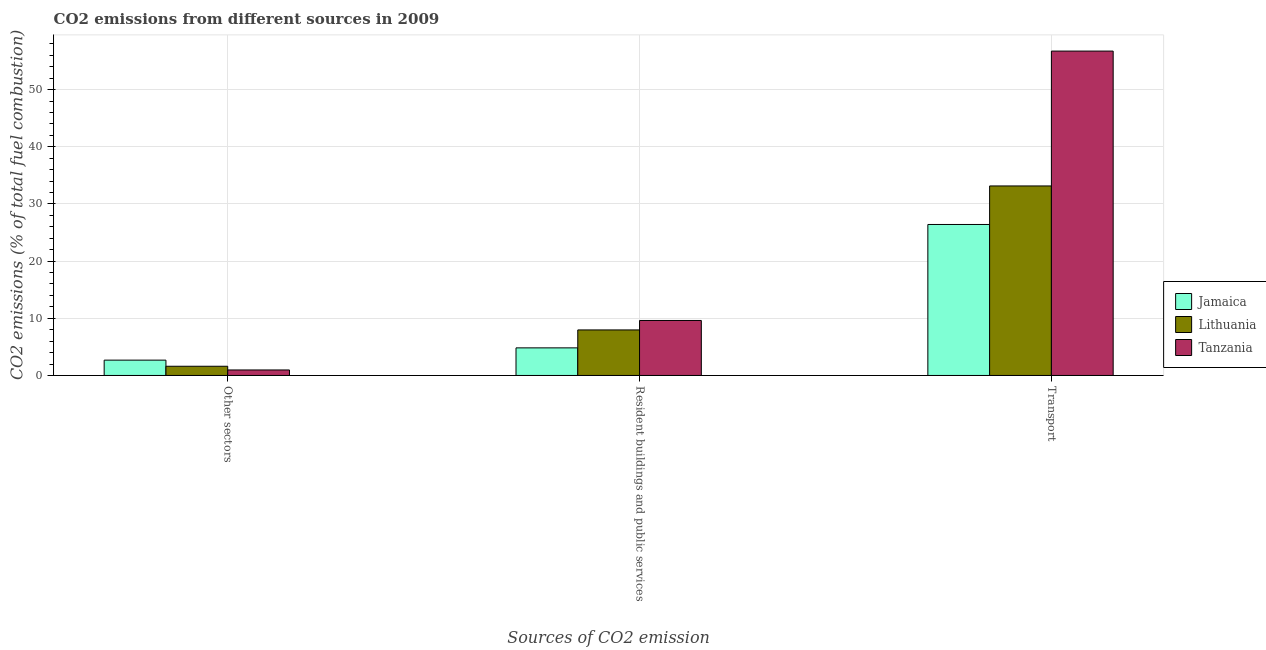How many different coloured bars are there?
Make the answer very short. 3. How many groups of bars are there?
Provide a succinct answer. 3. Are the number of bars on each tick of the X-axis equal?
Your answer should be compact. Yes. How many bars are there on the 3rd tick from the left?
Offer a very short reply. 3. How many bars are there on the 3rd tick from the right?
Give a very brief answer. 3. What is the label of the 1st group of bars from the left?
Your answer should be compact. Other sectors. What is the percentage of co2 emissions from other sectors in Lithuania?
Offer a terse response. 1.61. Across all countries, what is the maximum percentage of co2 emissions from resident buildings and public services?
Offer a terse response. 9.62. Across all countries, what is the minimum percentage of co2 emissions from other sectors?
Make the answer very short. 0.96. In which country was the percentage of co2 emissions from resident buildings and public services maximum?
Provide a short and direct response. Tanzania. In which country was the percentage of co2 emissions from transport minimum?
Provide a short and direct response. Jamaica. What is the total percentage of co2 emissions from other sectors in the graph?
Ensure brevity in your answer.  5.25. What is the difference between the percentage of co2 emissions from other sectors in Jamaica and that in Lithuania?
Offer a terse response. 1.07. What is the difference between the percentage of co2 emissions from transport in Jamaica and the percentage of co2 emissions from other sectors in Lithuania?
Make the answer very short. 24.8. What is the average percentage of co2 emissions from transport per country?
Give a very brief answer. 38.76. What is the difference between the percentage of co2 emissions from resident buildings and public services and percentage of co2 emissions from transport in Tanzania?
Offer a very short reply. -47.12. What is the ratio of the percentage of co2 emissions from resident buildings and public services in Tanzania to that in Jamaica?
Give a very brief answer. 1.99. What is the difference between the highest and the second highest percentage of co2 emissions from resident buildings and public services?
Offer a very short reply. 1.65. What is the difference between the highest and the lowest percentage of co2 emissions from other sectors?
Your answer should be compact. 1.72. In how many countries, is the percentage of co2 emissions from other sectors greater than the average percentage of co2 emissions from other sectors taken over all countries?
Your response must be concise. 1. Is the sum of the percentage of co2 emissions from other sectors in Tanzania and Jamaica greater than the maximum percentage of co2 emissions from transport across all countries?
Provide a succinct answer. No. What does the 1st bar from the left in Other sectors represents?
Provide a succinct answer. Jamaica. What does the 2nd bar from the right in Resident buildings and public services represents?
Provide a succinct answer. Lithuania. Is it the case that in every country, the sum of the percentage of co2 emissions from other sectors and percentage of co2 emissions from resident buildings and public services is greater than the percentage of co2 emissions from transport?
Provide a succinct answer. No. How many countries are there in the graph?
Offer a very short reply. 3. What is the difference between two consecutive major ticks on the Y-axis?
Your answer should be very brief. 10. Does the graph contain any zero values?
Offer a terse response. No. Does the graph contain grids?
Your response must be concise. Yes. How many legend labels are there?
Provide a short and direct response. 3. How are the legend labels stacked?
Give a very brief answer. Vertical. What is the title of the graph?
Your response must be concise. CO2 emissions from different sources in 2009. Does "Low & middle income" appear as one of the legend labels in the graph?
Provide a succinct answer. No. What is the label or title of the X-axis?
Your response must be concise. Sources of CO2 emission. What is the label or title of the Y-axis?
Provide a short and direct response. CO2 emissions (% of total fuel combustion). What is the CO2 emissions (% of total fuel combustion) in Jamaica in Other sectors?
Make the answer very short. 2.68. What is the CO2 emissions (% of total fuel combustion) of Lithuania in Other sectors?
Offer a terse response. 1.61. What is the CO2 emissions (% of total fuel combustion) in Tanzania in Other sectors?
Your answer should be compact. 0.96. What is the CO2 emissions (% of total fuel combustion) of Jamaica in Resident buildings and public services?
Keep it short and to the point. 4.83. What is the CO2 emissions (% of total fuel combustion) in Lithuania in Resident buildings and public services?
Give a very brief answer. 7.96. What is the CO2 emissions (% of total fuel combustion) in Tanzania in Resident buildings and public services?
Provide a succinct answer. 9.62. What is the CO2 emissions (% of total fuel combustion) of Jamaica in Transport?
Provide a short and direct response. 26.41. What is the CO2 emissions (% of total fuel combustion) in Lithuania in Transport?
Offer a terse response. 33.15. What is the CO2 emissions (% of total fuel combustion) in Tanzania in Transport?
Give a very brief answer. 56.73. Across all Sources of CO2 emission, what is the maximum CO2 emissions (% of total fuel combustion) in Jamaica?
Your answer should be very brief. 26.41. Across all Sources of CO2 emission, what is the maximum CO2 emissions (% of total fuel combustion) in Lithuania?
Your answer should be compact. 33.15. Across all Sources of CO2 emission, what is the maximum CO2 emissions (% of total fuel combustion) in Tanzania?
Provide a short and direct response. 56.73. Across all Sources of CO2 emission, what is the minimum CO2 emissions (% of total fuel combustion) in Jamaica?
Ensure brevity in your answer.  2.68. Across all Sources of CO2 emission, what is the minimum CO2 emissions (% of total fuel combustion) in Lithuania?
Offer a terse response. 1.61. Across all Sources of CO2 emission, what is the minimum CO2 emissions (% of total fuel combustion) of Tanzania?
Make the answer very short. 0.96. What is the total CO2 emissions (% of total fuel combustion) in Jamaica in the graph?
Provide a short and direct response. 33.91. What is the total CO2 emissions (% of total fuel combustion) in Lithuania in the graph?
Your response must be concise. 42.72. What is the total CO2 emissions (% of total fuel combustion) in Tanzania in the graph?
Offer a terse response. 67.31. What is the difference between the CO2 emissions (% of total fuel combustion) in Jamaica in Other sectors and that in Resident buildings and public services?
Ensure brevity in your answer.  -2.14. What is the difference between the CO2 emissions (% of total fuel combustion) of Lithuania in Other sectors and that in Resident buildings and public services?
Provide a succinct answer. -6.36. What is the difference between the CO2 emissions (% of total fuel combustion) of Tanzania in Other sectors and that in Resident buildings and public services?
Your response must be concise. -8.65. What is the difference between the CO2 emissions (% of total fuel combustion) of Jamaica in Other sectors and that in Transport?
Provide a succinct answer. -23.73. What is the difference between the CO2 emissions (% of total fuel combustion) of Lithuania in Other sectors and that in Transport?
Give a very brief answer. -31.54. What is the difference between the CO2 emissions (% of total fuel combustion) in Tanzania in Other sectors and that in Transport?
Provide a succinct answer. -55.77. What is the difference between the CO2 emissions (% of total fuel combustion) of Jamaica in Resident buildings and public services and that in Transport?
Offer a terse response. -21.58. What is the difference between the CO2 emissions (% of total fuel combustion) of Lithuania in Resident buildings and public services and that in Transport?
Your response must be concise. -25.18. What is the difference between the CO2 emissions (% of total fuel combustion) of Tanzania in Resident buildings and public services and that in Transport?
Offer a terse response. -47.12. What is the difference between the CO2 emissions (% of total fuel combustion) in Jamaica in Other sectors and the CO2 emissions (% of total fuel combustion) in Lithuania in Resident buildings and public services?
Keep it short and to the point. -5.28. What is the difference between the CO2 emissions (% of total fuel combustion) in Jamaica in Other sectors and the CO2 emissions (% of total fuel combustion) in Tanzania in Resident buildings and public services?
Ensure brevity in your answer.  -6.93. What is the difference between the CO2 emissions (% of total fuel combustion) of Lithuania in Other sectors and the CO2 emissions (% of total fuel combustion) of Tanzania in Resident buildings and public services?
Offer a very short reply. -8.01. What is the difference between the CO2 emissions (% of total fuel combustion) in Jamaica in Other sectors and the CO2 emissions (% of total fuel combustion) in Lithuania in Transport?
Your answer should be compact. -30.46. What is the difference between the CO2 emissions (% of total fuel combustion) of Jamaica in Other sectors and the CO2 emissions (% of total fuel combustion) of Tanzania in Transport?
Keep it short and to the point. -54.05. What is the difference between the CO2 emissions (% of total fuel combustion) in Lithuania in Other sectors and the CO2 emissions (% of total fuel combustion) in Tanzania in Transport?
Make the answer very short. -55.12. What is the difference between the CO2 emissions (% of total fuel combustion) of Jamaica in Resident buildings and public services and the CO2 emissions (% of total fuel combustion) of Lithuania in Transport?
Give a very brief answer. -28.32. What is the difference between the CO2 emissions (% of total fuel combustion) in Jamaica in Resident buildings and public services and the CO2 emissions (% of total fuel combustion) in Tanzania in Transport?
Your answer should be very brief. -51.91. What is the difference between the CO2 emissions (% of total fuel combustion) in Lithuania in Resident buildings and public services and the CO2 emissions (% of total fuel combustion) in Tanzania in Transport?
Offer a very short reply. -48.77. What is the average CO2 emissions (% of total fuel combustion) of Jamaica per Sources of CO2 emission?
Give a very brief answer. 11.3. What is the average CO2 emissions (% of total fuel combustion) in Lithuania per Sources of CO2 emission?
Keep it short and to the point. 14.24. What is the average CO2 emissions (% of total fuel combustion) of Tanzania per Sources of CO2 emission?
Your answer should be compact. 22.44. What is the difference between the CO2 emissions (% of total fuel combustion) of Jamaica and CO2 emissions (% of total fuel combustion) of Lithuania in Other sectors?
Offer a terse response. 1.07. What is the difference between the CO2 emissions (% of total fuel combustion) of Jamaica and CO2 emissions (% of total fuel combustion) of Tanzania in Other sectors?
Offer a very short reply. 1.72. What is the difference between the CO2 emissions (% of total fuel combustion) of Lithuania and CO2 emissions (% of total fuel combustion) of Tanzania in Other sectors?
Keep it short and to the point. 0.65. What is the difference between the CO2 emissions (% of total fuel combustion) in Jamaica and CO2 emissions (% of total fuel combustion) in Lithuania in Resident buildings and public services?
Offer a terse response. -3.14. What is the difference between the CO2 emissions (% of total fuel combustion) in Jamaica and CO2 emissions (% of total fuel combustion) in Tanzania in Resident buildings and public services?
Provide a succinct answer. -4.79. What is the difference between the CO2 emissions (% of total fuel combustion) of Lithuania and CO2 emissions (% of total fuel combustion) of Tanzania in Resident buildings and public services?
Provide a short and direct response. -1.65. What is the difference between the CO2 emissions (% of total fuel combustion) in Jamaica and CO2 emissions (% of total fuel combustion) in Lithuania in Transport?
Offer a very short reply. -6.74. What is the difference between the CO2 emissions (% of total fuel combustion) of Jamaica and CO2 emissions (% of total fuel combustion) of Tanzania in Transport?
Make the answer very short. -30.32. What is the difference between the CO2 emissions (% of total fuel combustion) in Lithuania and CO2 emissions (% of total fuel combustion) in Tanzania in Transport?
Your response must be concise. -23.59. What is the ratio of the CO2 emissions (% of total fuel combustion) in Jamaica in Other sectors to that in Resident buildings and public services?
Your response must be concise. 0.56. What is the ratio of the CO2 emissions (% of total fuel combustion) of Lithuania in Other sectors to that in Resident buildings and public services?
Provide a succinct answer. 0.2. What is the ratio of the CO2 emissions (% of total fuel combustion) in Jamaica in Other sectors to that in Transport?
Your answer should be compact. 0.1. What is the ratio of the CO2 emissions (% of total fuel combustion) in Lithuania in Other sectors to that in Transport?
Keep it short and to the point. 0.05. What is the ratio of the CO2 emissions (% of total fuel combustion) in Tanzania in Other sectors to that in Transport?
Make the answer very short. 0.02. What is the ratio of the CO2 emissions (% of total fuel combustion) in Jamaica in Resident buildings and public services to that in Transport?
Keep it short and to the point. 0.18. What is the ratio of the CO2 emissions (% of total fuel combustion) in Lithuania in Resident buildings and public services to that in Transport?
Make the answer very short. 0.24. What is the ratio of the CO2 emissions (% of total fuel combustion) in Tanzania in Resident buildings and public services to that in Transport?
Give a very brief answer. 0.17. What is the difference between the highest and the second highest CO2 emissions (% of total fuel combustion) of Jamaica?
Provide a short and direct response. 21.58. What is the difference between the highest and the second highest CO2 emissions (% of total fuel combustion) of Lithuania?
Ensure brevity in your answer.  25.18. What is the difference between the highest and the second highest CO2 emissions (% of total fuel combustion) in Tanzania?
Ensure brevity in your answer.  47.12. What is the difference between the highest and the lowest CO2 emissions (% of total fuel combustion) in Jamaica?
Give a very brief answer. 23.73. What is the difference between the highest and the lowest CO2 emissions (% of total fuel combustion) of Lithuania?
Make the answer very short. 31.54. What is the difference between the highest and the lowest CO2 emissions (% of total fuel combustion) in Tanzania?
Ensure brevity in your answer.  55.77. 